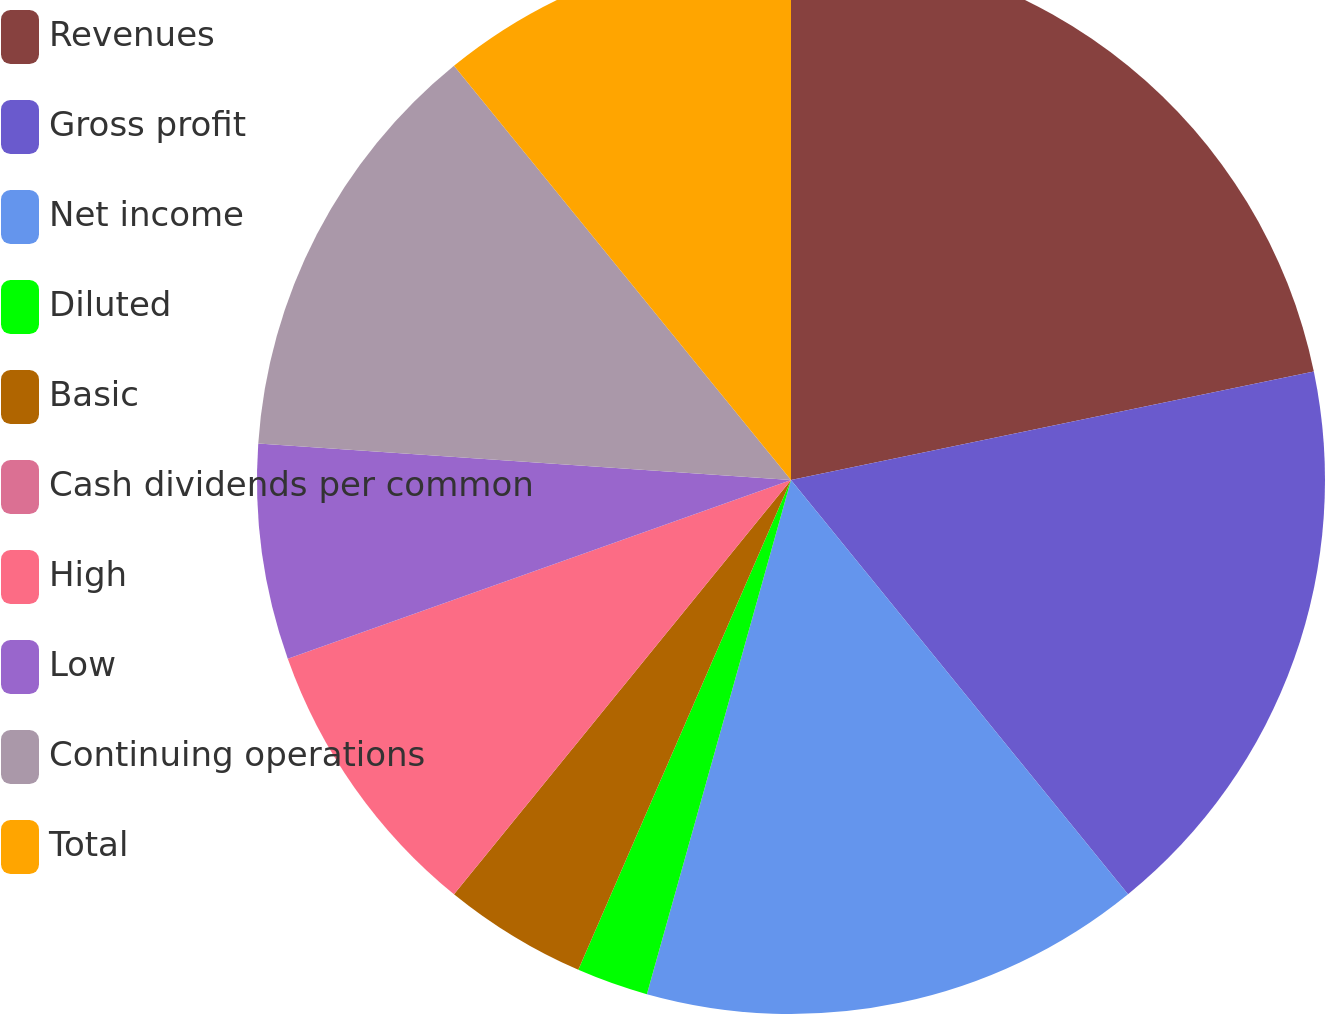Convert chart. <chart><loc_0><loc_0><loc_500><loc_500><pie_chart><fcel>Revenues<fcel>Gross profit<fcel>Net income<fcel>Diluted<fcel>Basic<fcel>Cash dividends per common<fcel>High<fcel>Low<fcel>Continuing operations<fcel>Total<nl><fcel>21.74%<fcel>17.39%<fcel>15.22%<fcel>2.17%<fcel>4.35%<fcel>0.0%<fcel>8.7%<fcel>6.52%<fcel>13.04%<fcel>10.87%<nl></chart> 